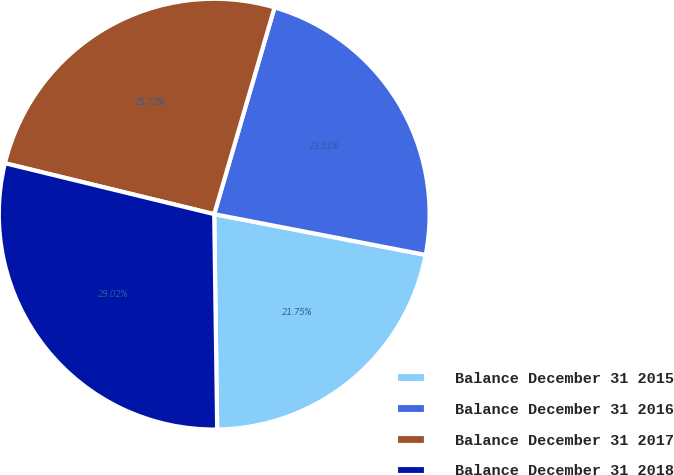Convert chart. <chart><loc_0><loc_0><loc_500><loc_500><pie_chart><fcel>Balance December 31 2015<fcel>Balance December 31 2016<fcel>Balance December 31 2017<fcel>Balance December 31 2018<nl><fcel>21.75%<fcel>23.51%<fcel>25.72%<fcel>29.02%<nl></chart> 